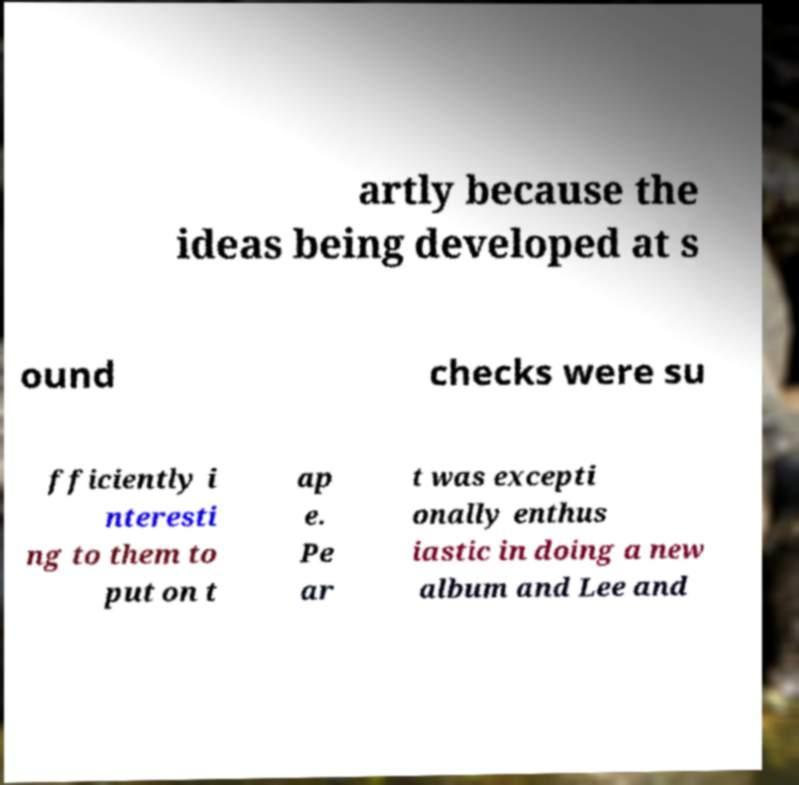Could you extract and type out the text from this image? artly because the ideas being developed at s ound checks were su fficiently i nteresti ng to them to put on t ap e. Pe ar t was excepti onally enthus iastic in doing a new album and Lee and 